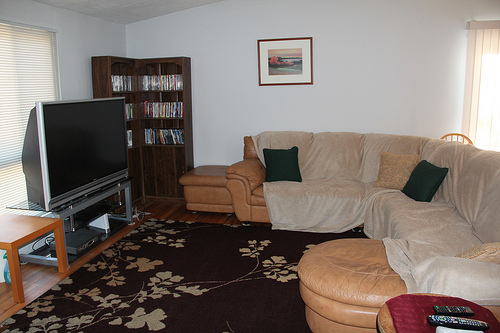Please provide a short description for this region: [0.65, 0.19, 0.89, 0.41]. This section depicts a plain white wall behind the couch, offering a simple, serene backdrop that contrasts with the other elements in the room. 